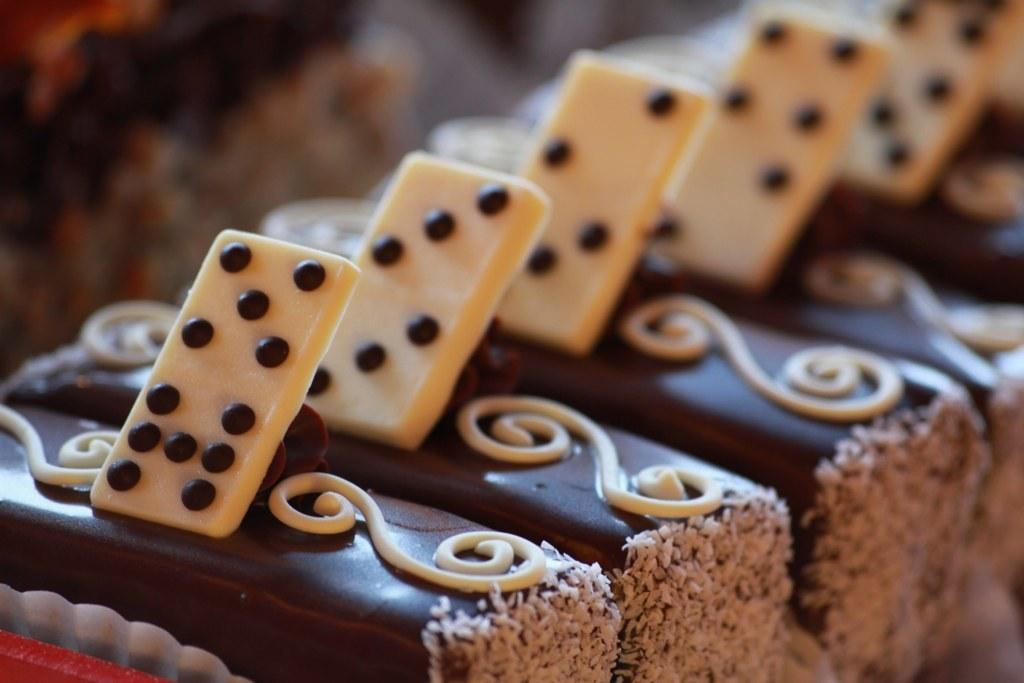What type of food is visible in the image? There are desserts in the image. How are the desserts arranged in the image? The desserts are arranged in a row. What type of neck accessory can be seen on the desserts in the image? There are no neck accessories present on the desserts in the image. 